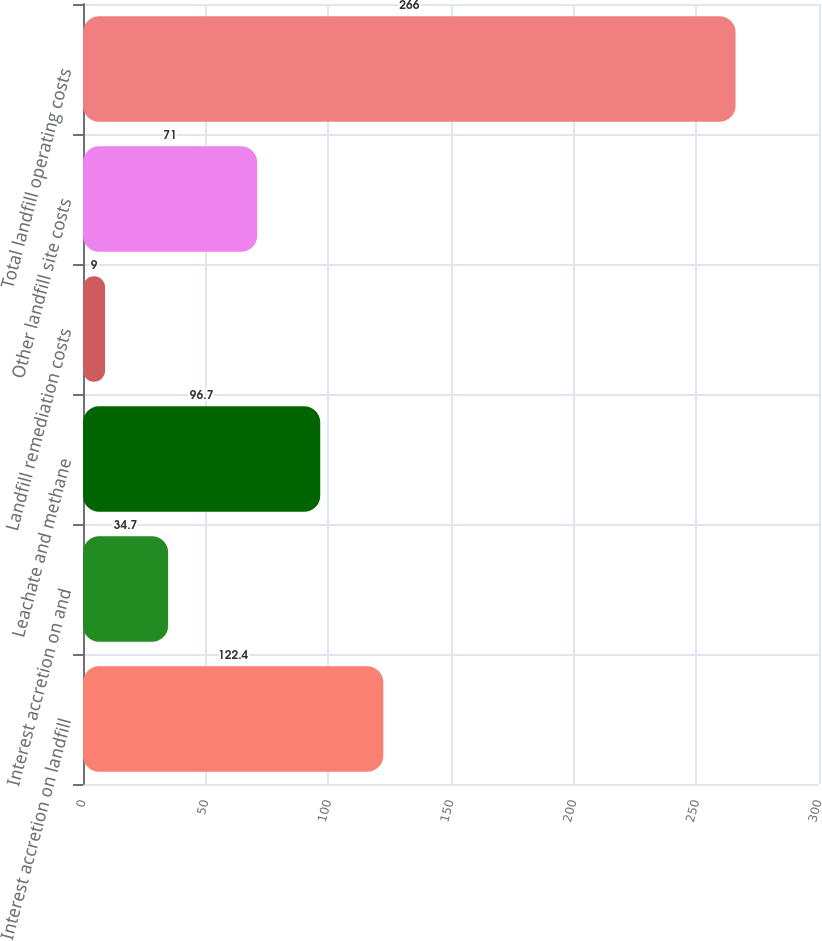Convert chart. <chart><loc_0><loc_0><loc_500><loc_500><bar_chart><fcel>Interest accretion on landfill<fcel>Interest accretion on and<fcel>Leachate and methane<fcel>Landfill remediation costs<fcel>Other landfill site costs<fcel>Total landfill operating costs<nl><fcel>122.4<fcel>34.7<fcel>96.7<fcel>9<fcel>71<fcel>266<nl></chart> 